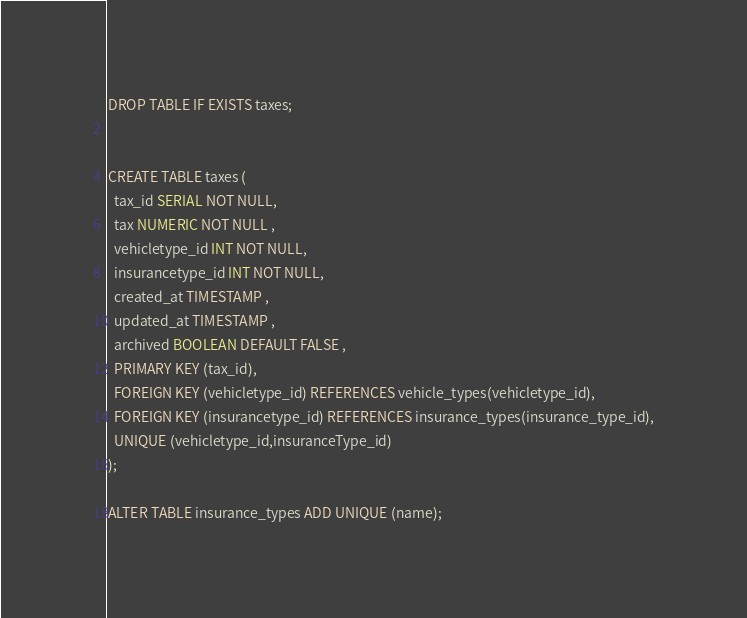<code> <loc_0><loc_0><loc_500><loc_500><_SQL_>DROP TABLE IF EXISTS taxes;


CREATE TABLE taxes (
  tax_id SERIAL NOT NULL,
  tax NUMERIC NOT NULL ,
  vehicletype_id INT NOT NULL,
  insurancetype_id INT NOT NULL,
  created_at TIMESTAMP ,
  updated_at TIMESTAMP ,
  archived BOOLEAN DEFAULT FALSE ,
  PRIMARY KEY (tax_id),
  FOREIGN KEY (vehicletype_id) REFERENCES vehicle_types(vehicletype_id),
  FOREIGN KEY (insurancetype_id) REFERENCES insurance_types(insurance_type_id),
  UNIQUE (vehicletype_id,insuranceType_id)
);

ALTER TABLE insurance_types ADD UNIQUE (name);</code> 